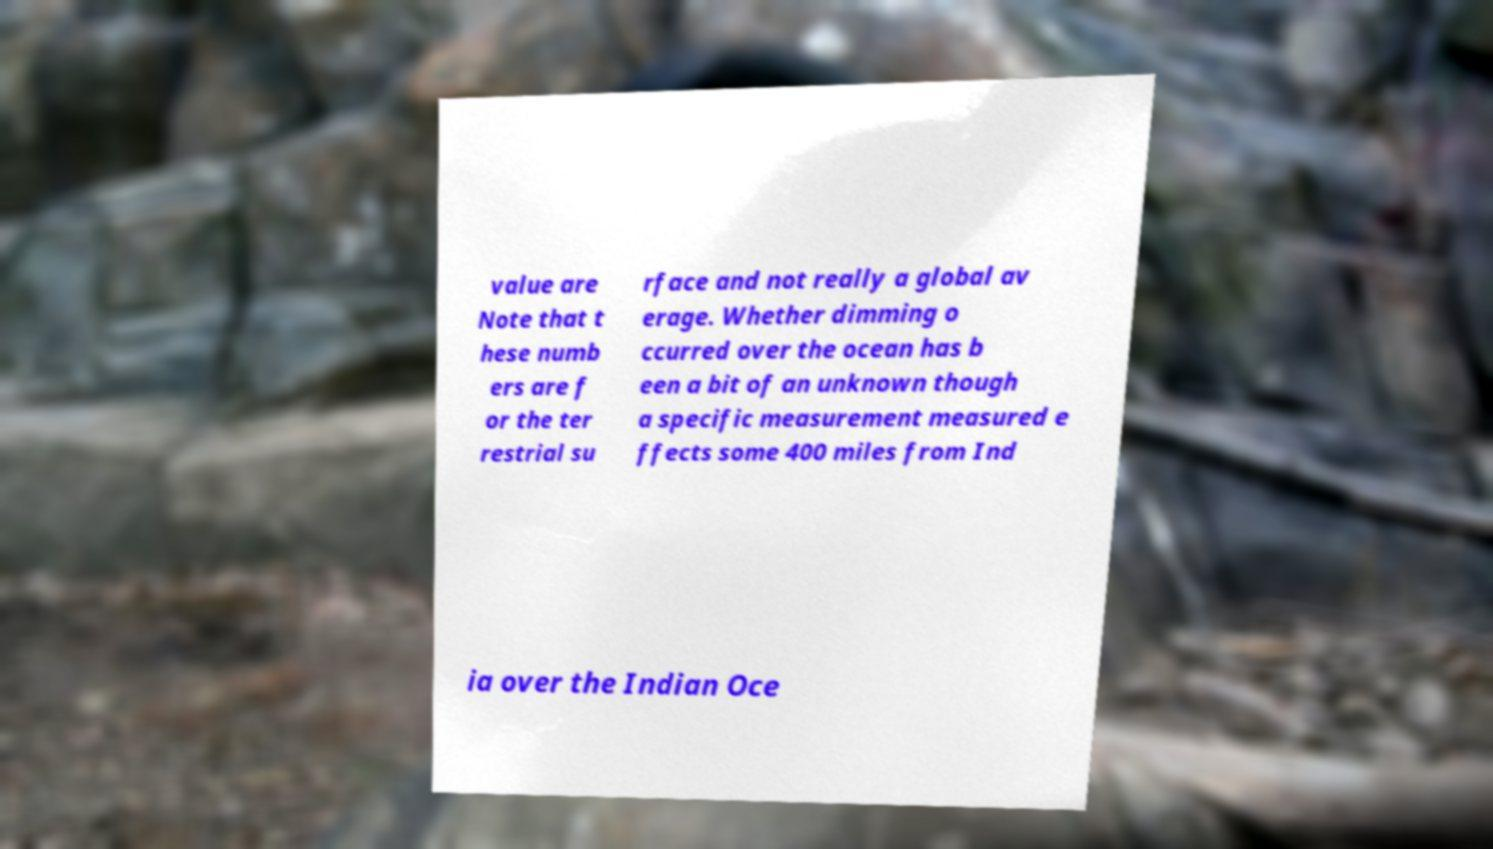Could you assist in decoding the text presented in this image and type it out clearly? value are Note that t hese numb ers are f or the ter restrial su rface and not really a global av erage. Whether dimming o ccurred over the ocean has b een a bit of an unknown though a specific measurement measured e ffects some 400 miles from Ind ia over the Indian Oce 